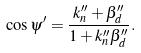Convert formula to latex. <formula><loc_0><loc_0><loc_500><loc_500>\cos \psi ^ { \prime } = \frac { k _ { n } ^ { \prime \prime } + \beta _ { d } ^ { \prime \prime } } { 1 + k _ { n } ^ { \prime \prime } \beta _ { d } ^ { \prime \prime } } .</formula> 